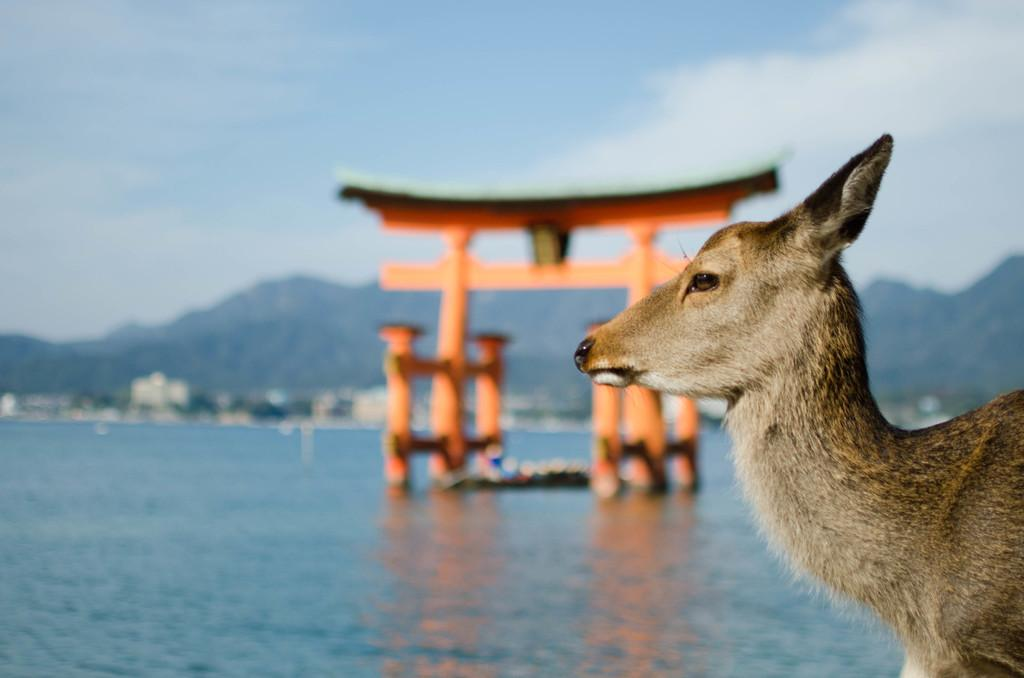What type of animal is in the image? There is an animal in the image, but the specific type cannot be determined from the provided facts. What can be seen in the background of the image? In the background of the image, there are mountains, water, and the sky. What color are the objects in the water? The objects in the water are orange. How is the background of the image depicted? The background of the image is blurred. What advice does the animal's brother give in the image? There is no mention of a brother or any advice-giving in the image. 